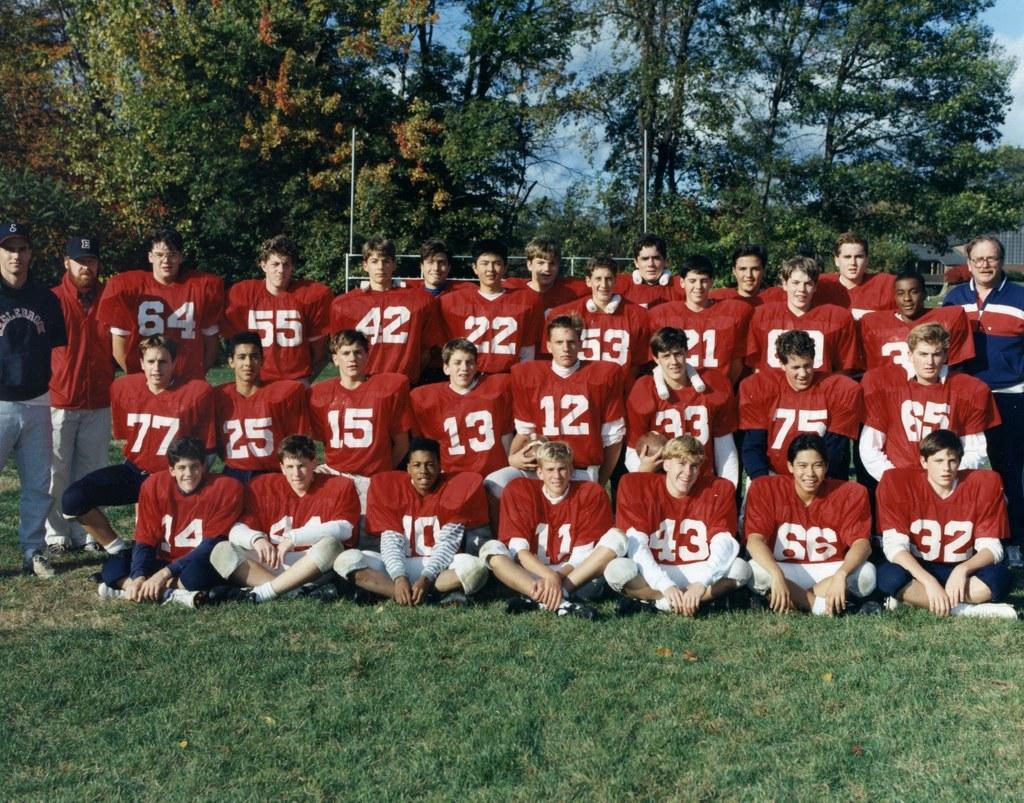In one or two sentences, can you explain what this image depicts? In this picture we can see some people standing and some people sitting, at the bottom there is grass, we can see trees in the background, there is the sky at the top of the picture. 